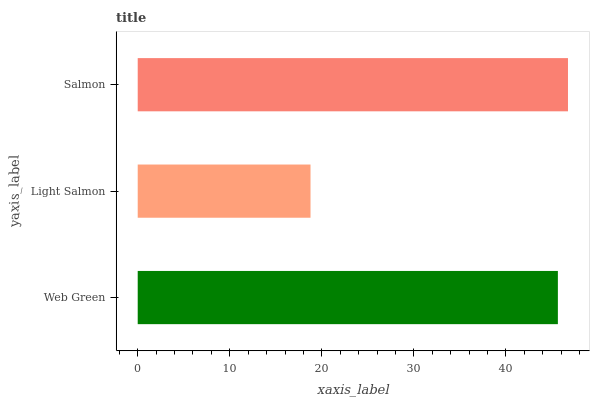Is Light Salmon the minimum?
Answer yes or no. Yes. Is Salmon the maximum?
Answer yes or no. Yes. Is Salmon the minimum?
Answer yes or no. No. Is Light Salmon the maximum?
Answer yes or no. No. Is Salmon greater than Light Salmon?
Answer yes or no. Yes. Is Light Salmon less than Salmon?
Answer yes or no. Yes. Is Light Salmon greater than Salmon?
Answer yes or no. No. Is Salmon less than Light Salmon?
Answer yes or no. No. Is Web Green the high median?
Answer yes or no. Yes. Is Web Green the low median?
Answer yes or no. Yes. Is Salmon the high median?
Answer yes or no. No. Is Salmon the low median?
Answer yes or no. No. 